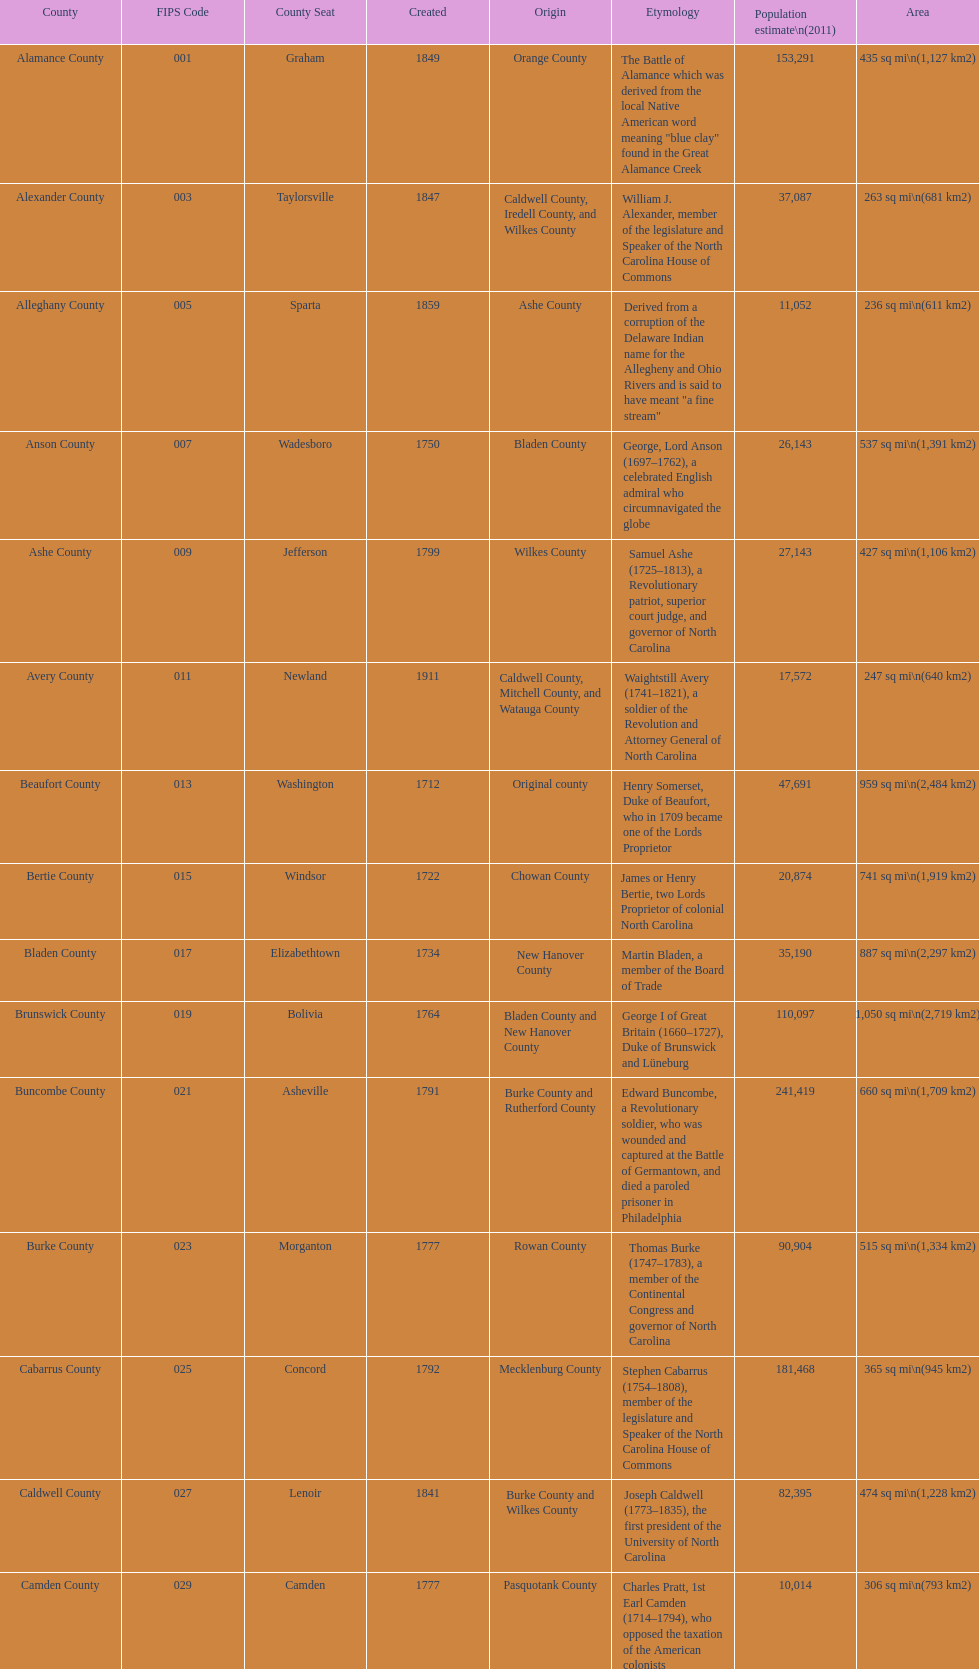What number of counties are named for us presidents? 3. 